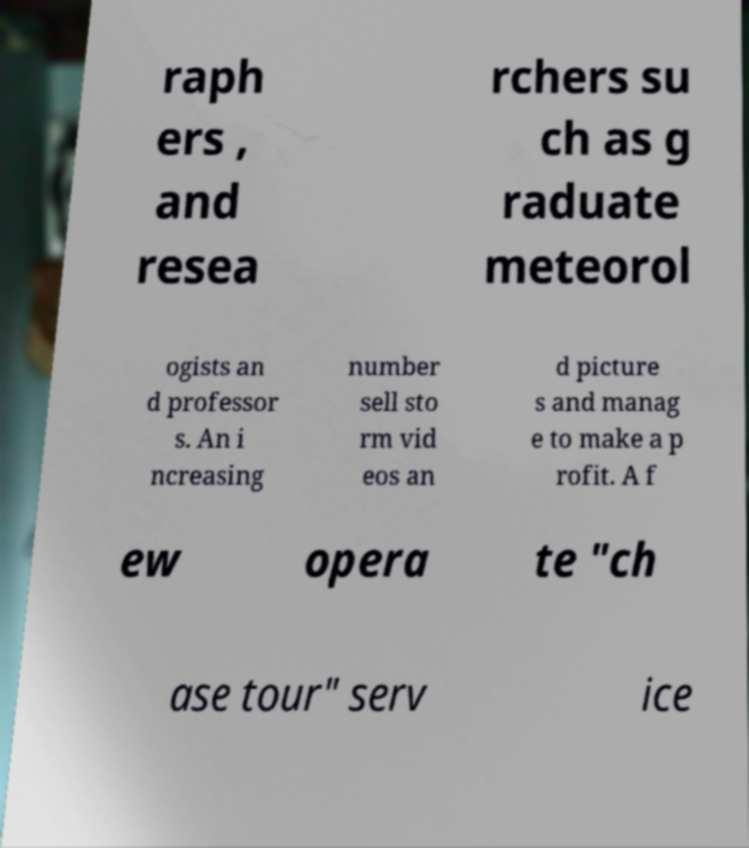There's text embedded in this image that I need extracted. Can you transcribe it verbatim? raph ers , and resea rchers su ch as g raduate meteorol ogists an d professor s. An i ncreasing number sell sto rm vid eos an d picture s and manag e to make a p rofit. A f ew opera te "ch ase tour" serv ice 